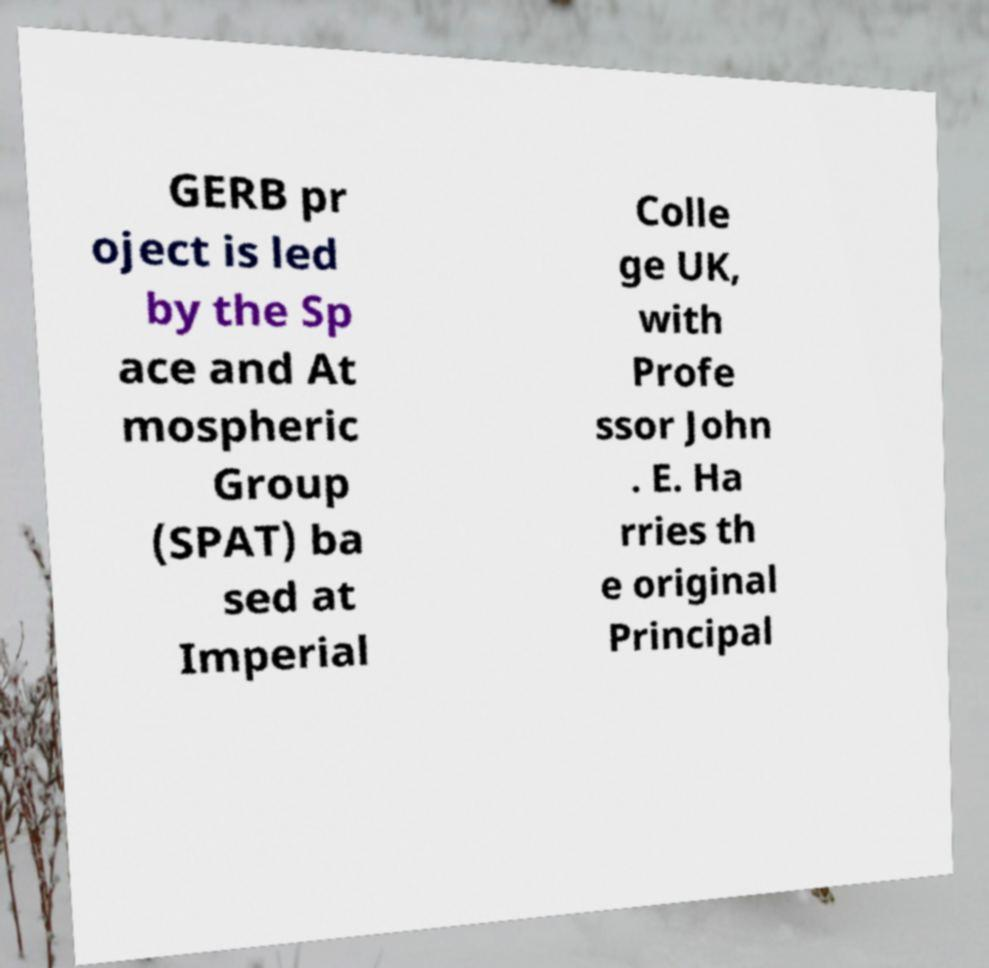Please read and relay the text visible in this image. What does it say? GERB pr oject is led by the Sp ace and At mospheric Group (SPAT) ba sed at Imperial Colle ge UK, with Profe ssor John . E. Ha rries th e original Principal 